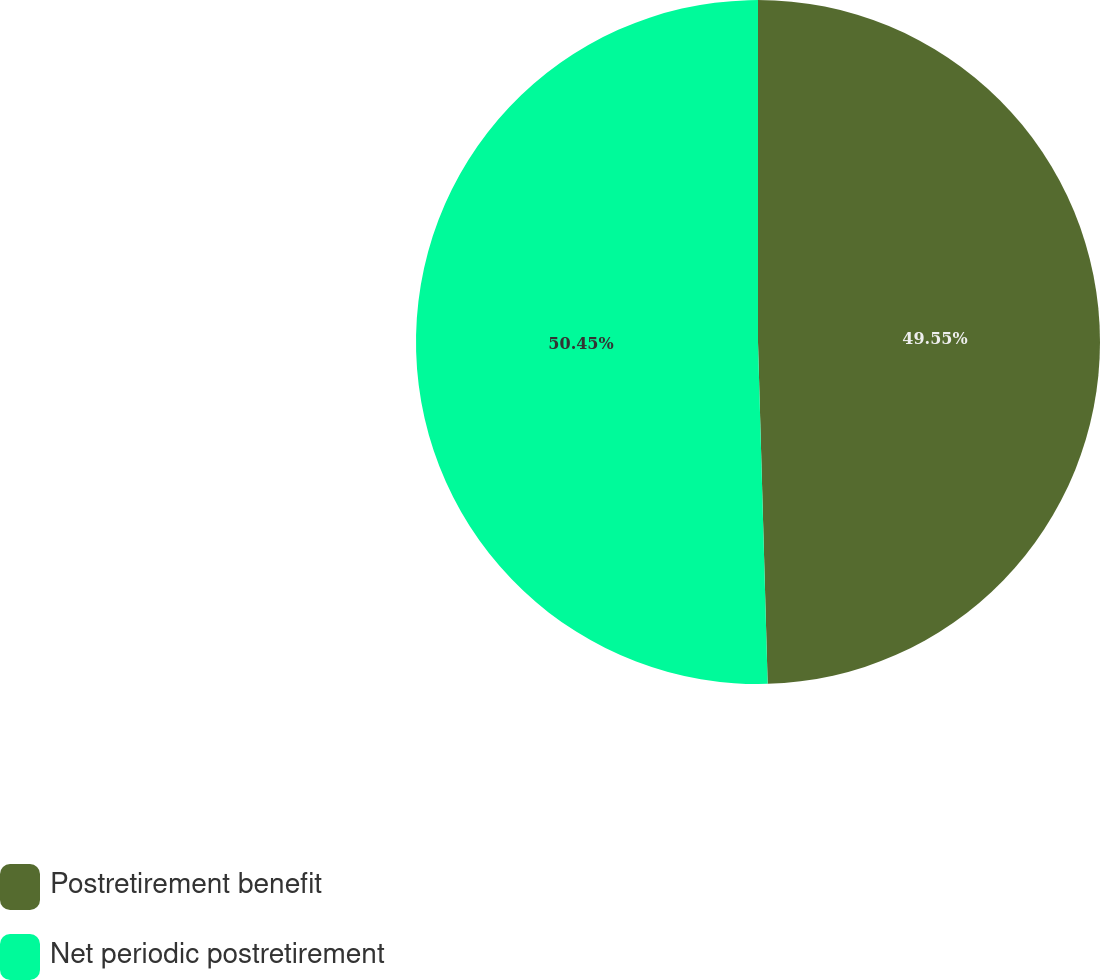<chart> <loc_0><loc_0><loc_500><loc_500><pie_chart><fcel>Postretirement benefit<fcel>Net periodic postretirement<nl><fcel>49.55%<fcel>50.45%<nl></chart> 